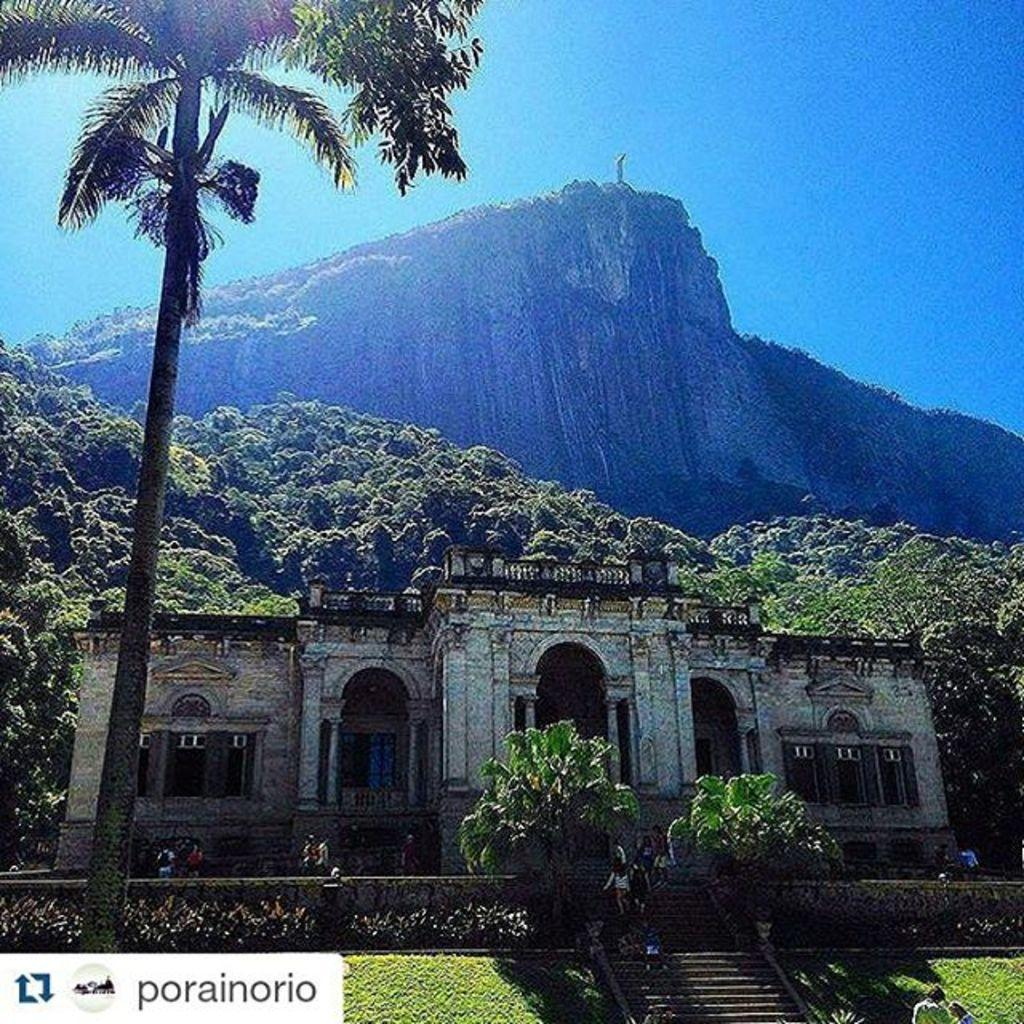How many people are in the group visible in the image? There is a group of people in the image, but the exact number cannot be determined from the provided facts. What type of structure is present in the image? There is a building in the image. What other natural elements can be seen in the image? There are trees and a hill visible in the image. What is visible in the background of the image? The sky is visible in the background of the image. What type of hair can be seen on the bone in the image? There is no bone or hair present in the image. What is the birth date of the person in the image? The provided facts do not mention any specific person or their birth date. 